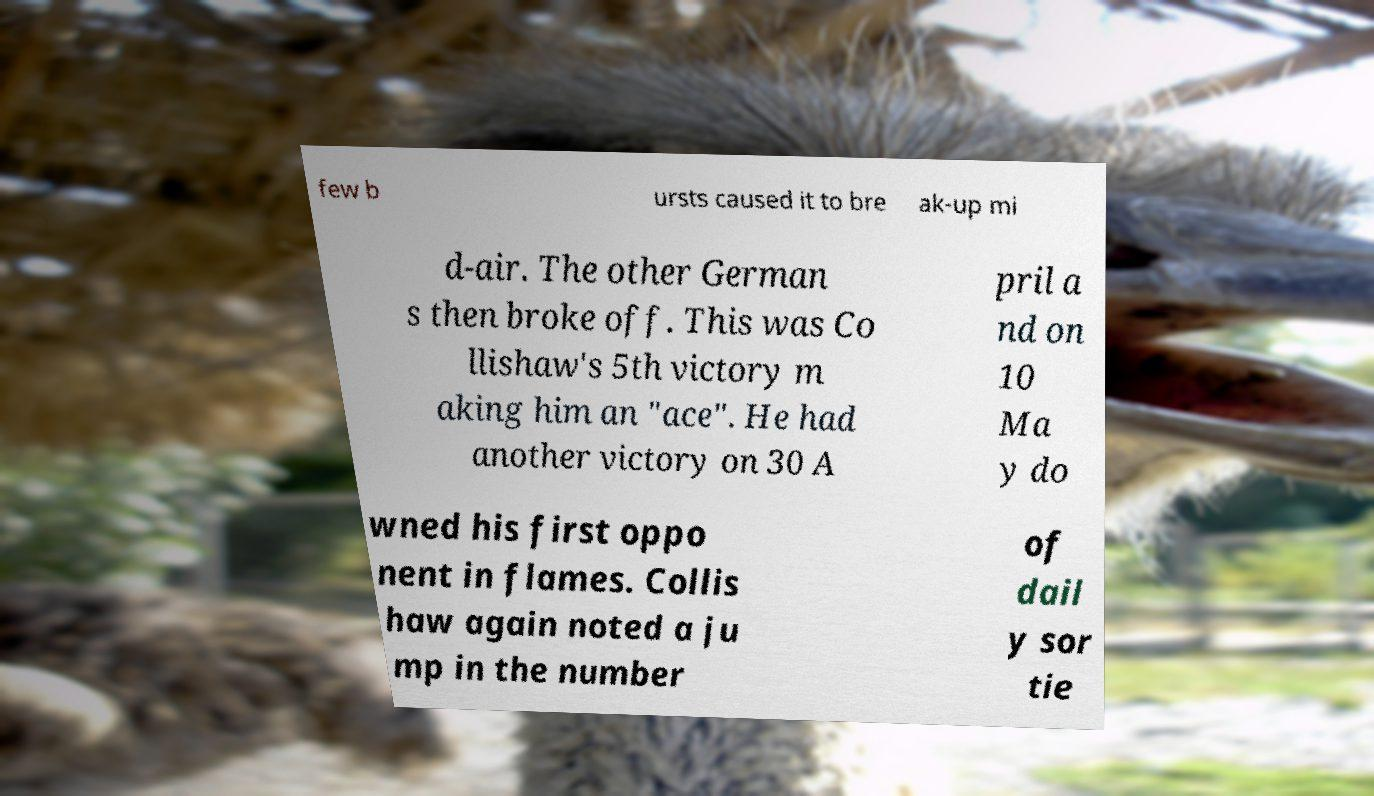For documentation purposes, I need the text within this image transcribed. Could you provide that? few b ursts caused it to bre ak-up mi d-air. The other German s then broke off. This was Co llishaw's 5th victory m aking him an "ace". He had another victory on 30 A pril a nd on 10 Ma y do wned his first oppo nent in flames. Collis haw again noted a ju mp in the number of dail y sor tie 